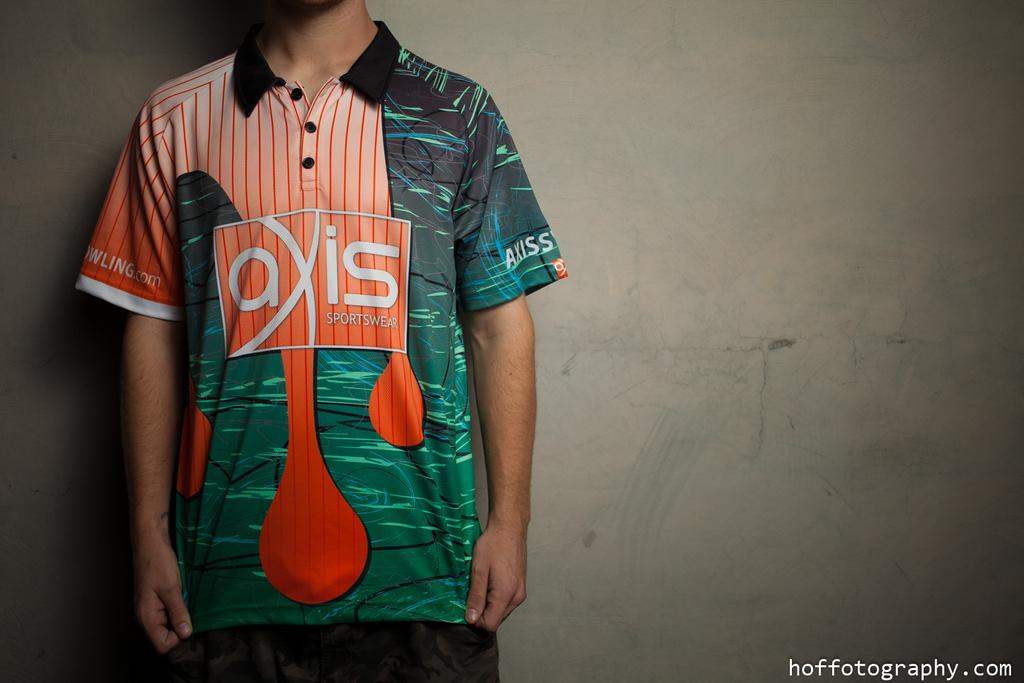Provide a one-sentence caption for the provided image. a shirt that has the word axis on it. 